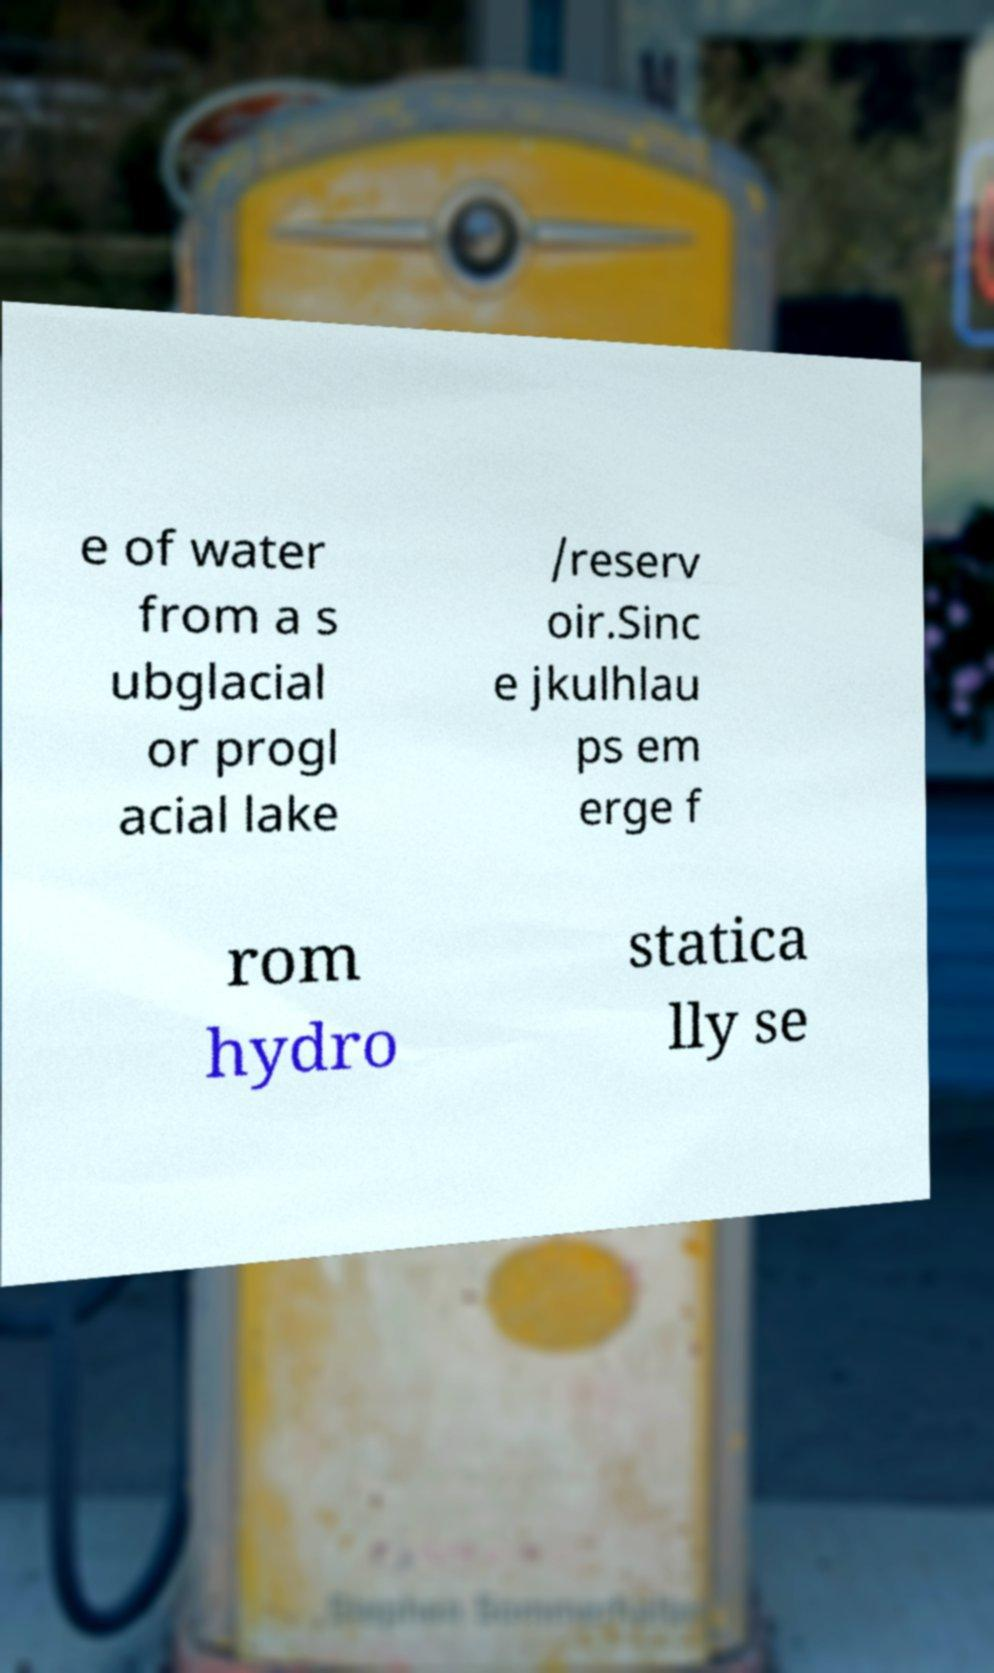What messages or text are displayed in this image? I need them in a readable, typed format. e of water from a s ubglacial or progl acial lake /reserv oir.Sinc e jkulhlau ps em erge f rom hydro statica lly se 